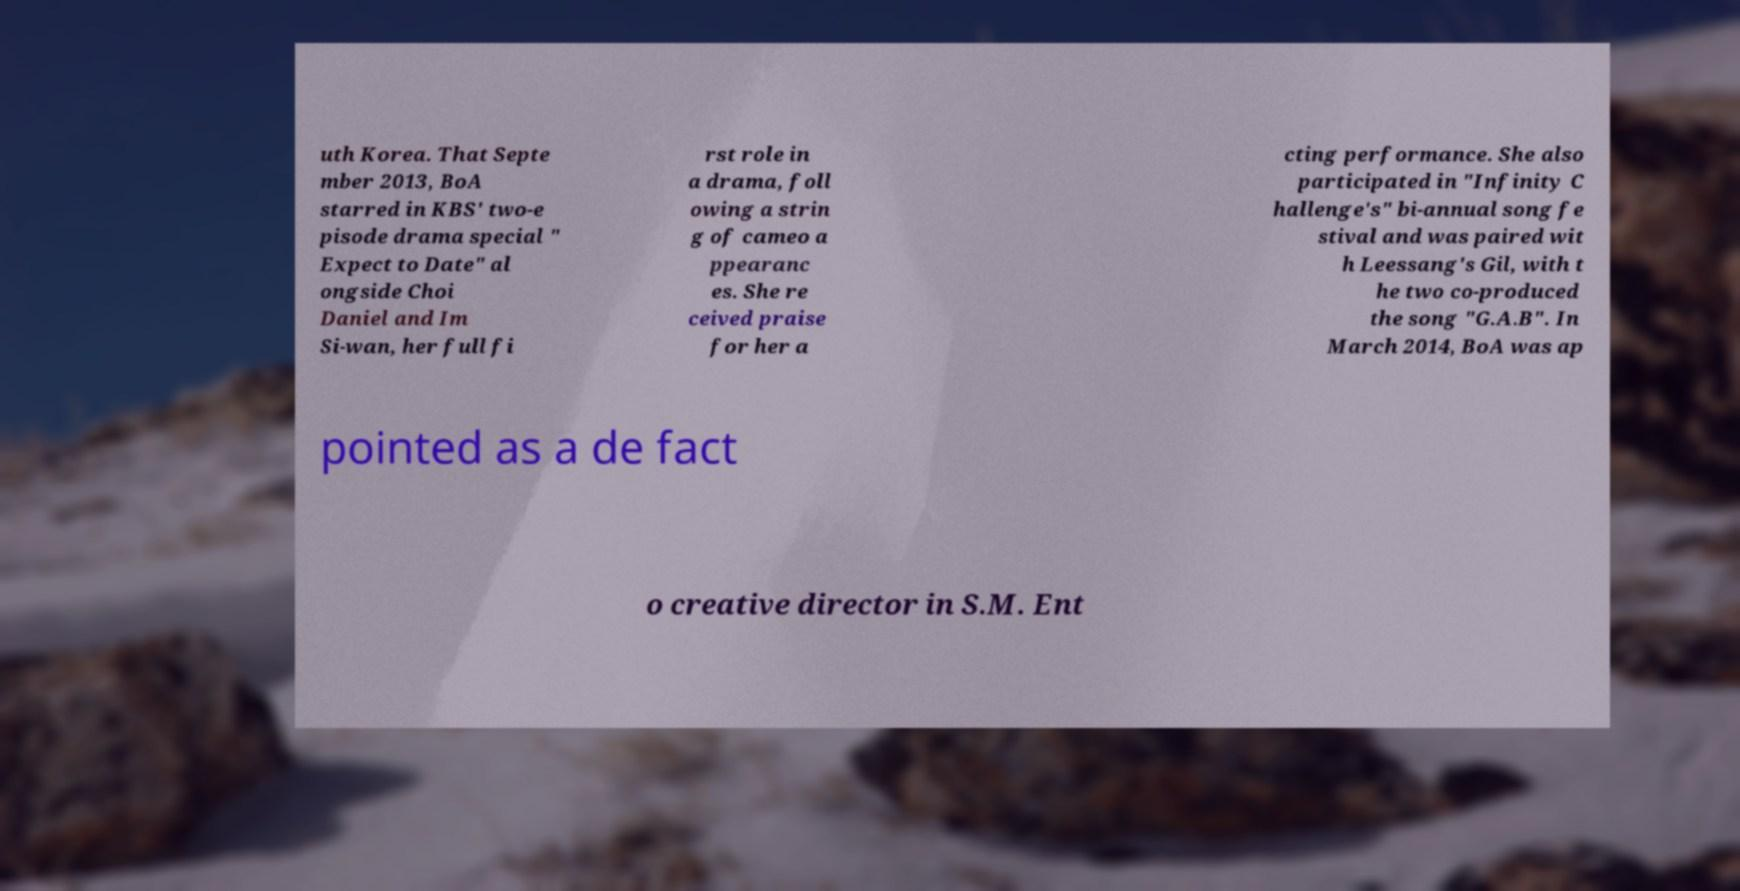Can you accurately transcribe the text from the provided image for me? uth Korea. That Septe mber 2013, BoA starred in KBS' two-e pisode drama special " Expect to Date" al ongside Choi Daniel and Im Si-wan, her full fi rst role in a drama, foll owing a strin g of cameo a ppearanc es. She re ceived praise for her a cting performance. She also participated in "Infinity C hallenge's" bi-annual song fe stival and was paired wit h Leessang's Gil, with t he two co-produced the song "G.A.B". In March 2014, BoA was ap pointed as a de fact o creative director in S.M. Ent 